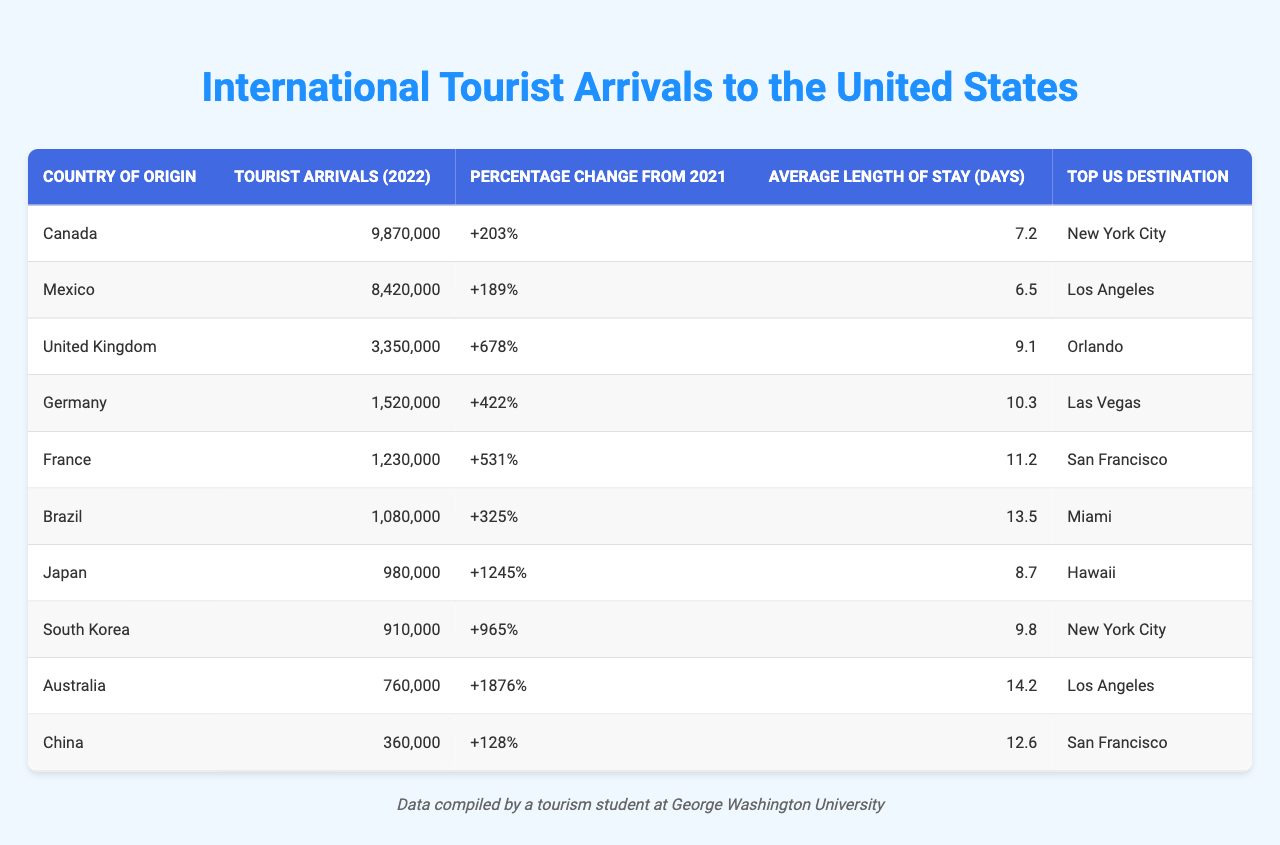What country had the highest tourist arrivals in 2022? The table shows the column “Tourist Arrivals (2022)” where Canada has 9,870,000 arrivals, which is the highest listed.
Answer: Canada Which country recorded the lowest tourist arrivals in 2022? By looking at the column for “Tourist Arrivals (2022),” China has the lowest value at 360,000 arrivals.
Answer: China What was the average length of stay for tourists from Australia? The table indicates that the average length of stay for Australian tourists is listed in the column “Average Length of Stay (days)” which is 14.2 days.
Answer: 14.2 Which country shows the greatest percentage change in tourist arrivals from 2021 to 2022? Checking the column "Percentage Change from 2021," Japan has the highest increase of +1245%.
Answer: Japan How many more tourist arrivals did Canada have compared to China in 2022? The tourist arrivals for Canada are 9,870,000 and for China are 360,000. The difference is calculated as 9,870,000 - 360,000 = 9,510,000.
Answer: 9,510,000 Is the average length of stay longer for tourists from Brazil or Mexico? For Brazil, the length of stay is 13.5 days, while Mexico's is 6.5 days. Since 13.5 > 6.5, Brazil has a longer stay.
Answer: Yes, Brazil What is the total number of tourist arrivals from Germany and France combined in 2022? Adding the arrivals from Germany (1,520,000) and France (1,230,000) gives a total of 1,520,000 + 1,230,000 = 2,750,000.
Answer: 2,750,000 Which top US destination is preferred by the most tourists from the United Kingdom? In the table, the top destination for the United Kingdom is listed as Orlando.
Answer: Orlando How does the average length of stay for Japan compare to that of South Korea? The average length of stay for Japan is 8.7 days and for South Korea, it is 9.8 days. Comparing these, South Korea has a longer stay which is 9.8 > 8.7.
Answer: South Korea is longer Which two countries have the same top US destination? The table shows that both Canada and South Korea have their top US destination listed as New York City.
Answer: Canada and South Korea 